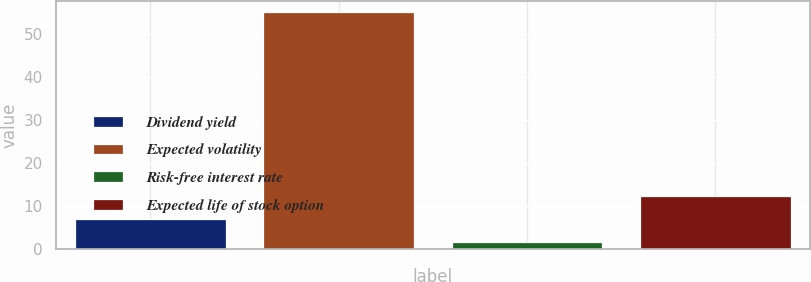Convert chart. <chart><loc_0><loc_0><loc_500><loc_500><bar_chart><fcel>Dividend yield<fcel>Expected volatility<fcel>Risk-free interest rate<fcel>Expected life of stock option<nl><fcel>7.12<fcel>55<fcel>1.8<fcel>12.44<nl></chart> 